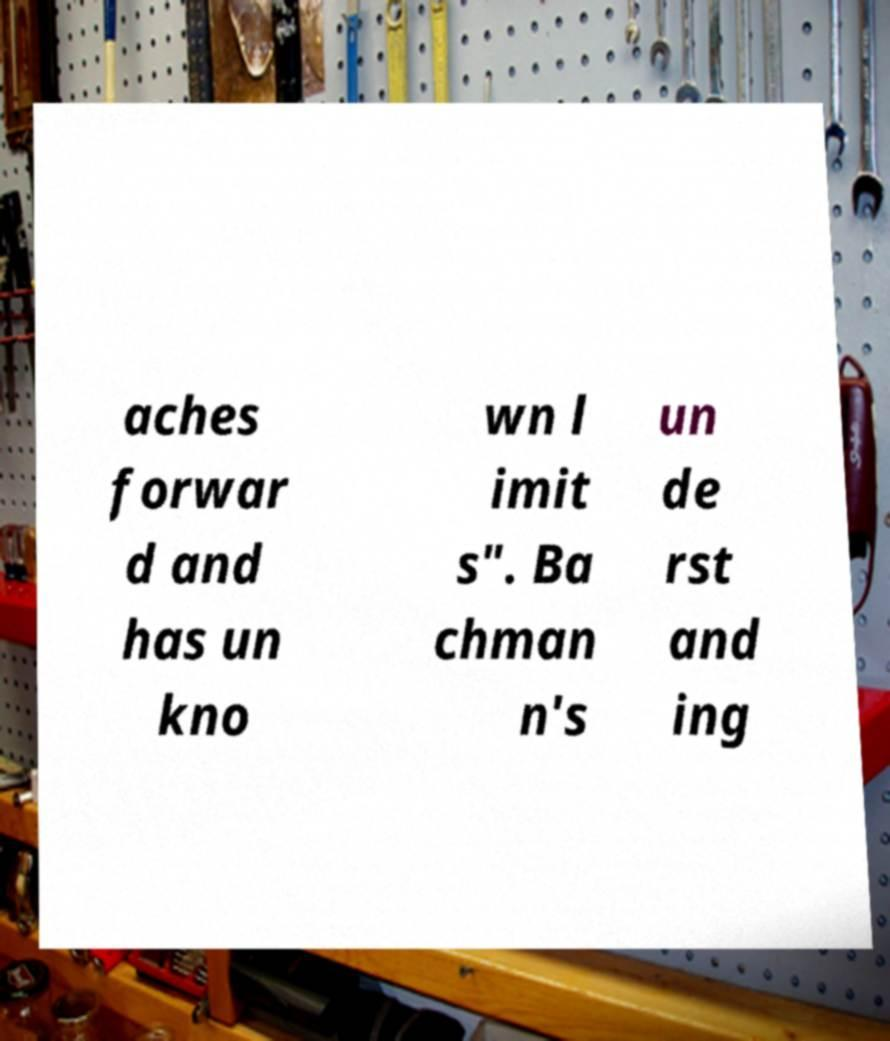There's text embedded in this image that I need extracted. Can you transcribe it verbatim? aches forwar d and has un kno wn l imit s". Ba chman n's un de rst and ing 